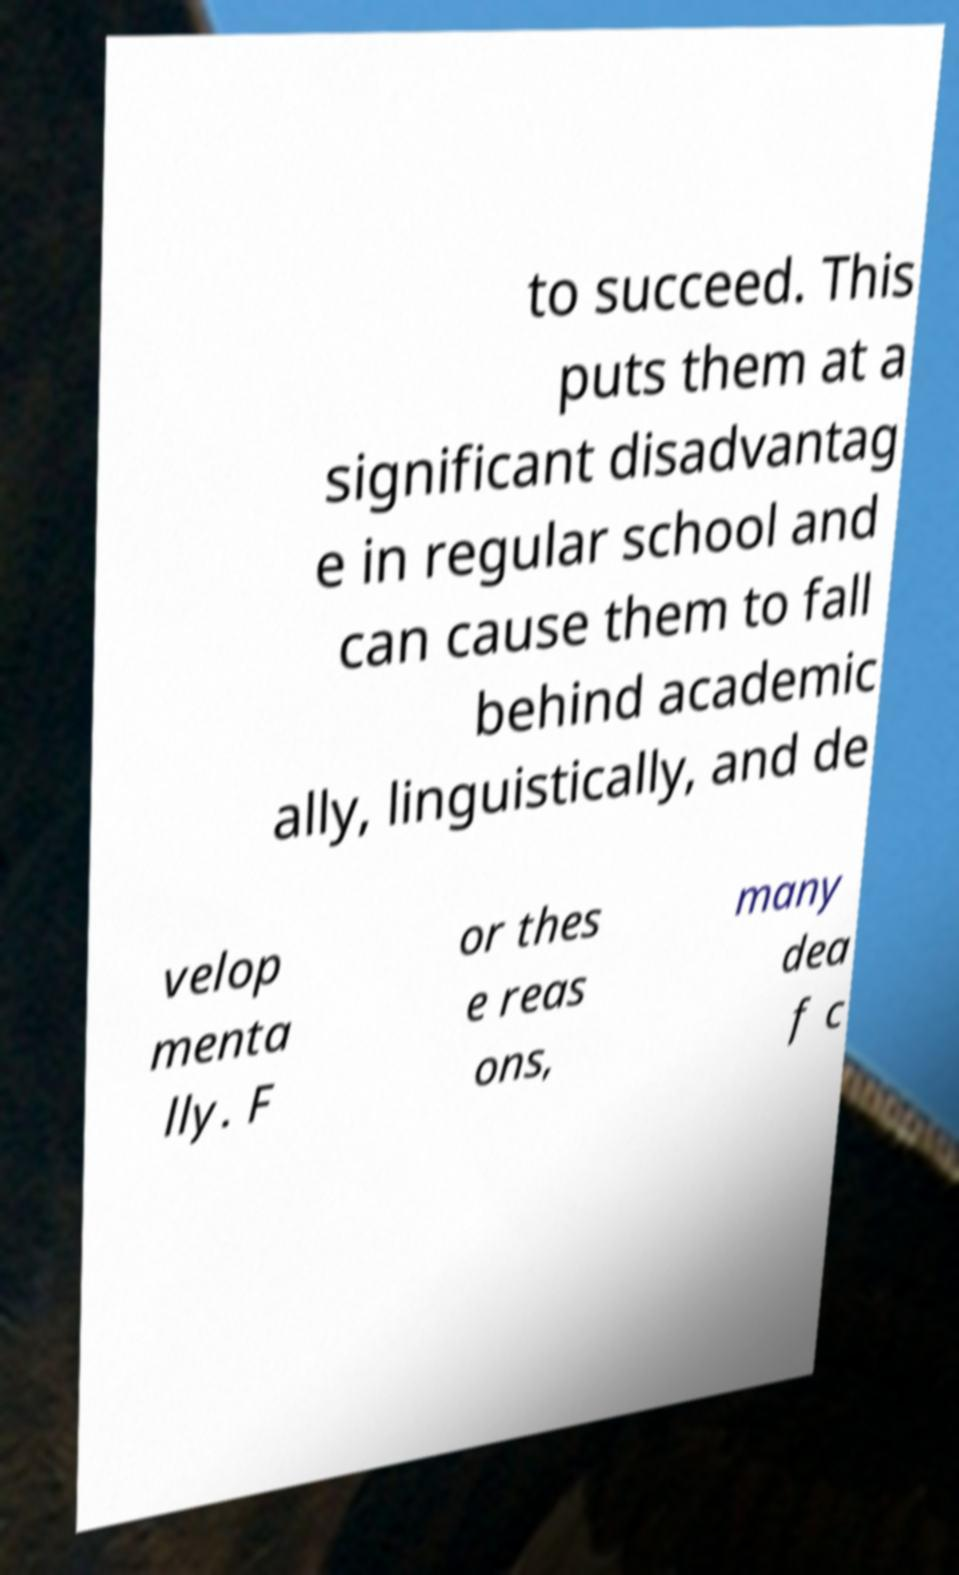Could you assist in decoding the text presented in this image and type it out clearly? to succeed. This puts them at a significant disadvantag e in regular school and can cause them to fall behind academic ally, linguistically, and de velop menta lly. F or thes e reas ons, many dea f c 